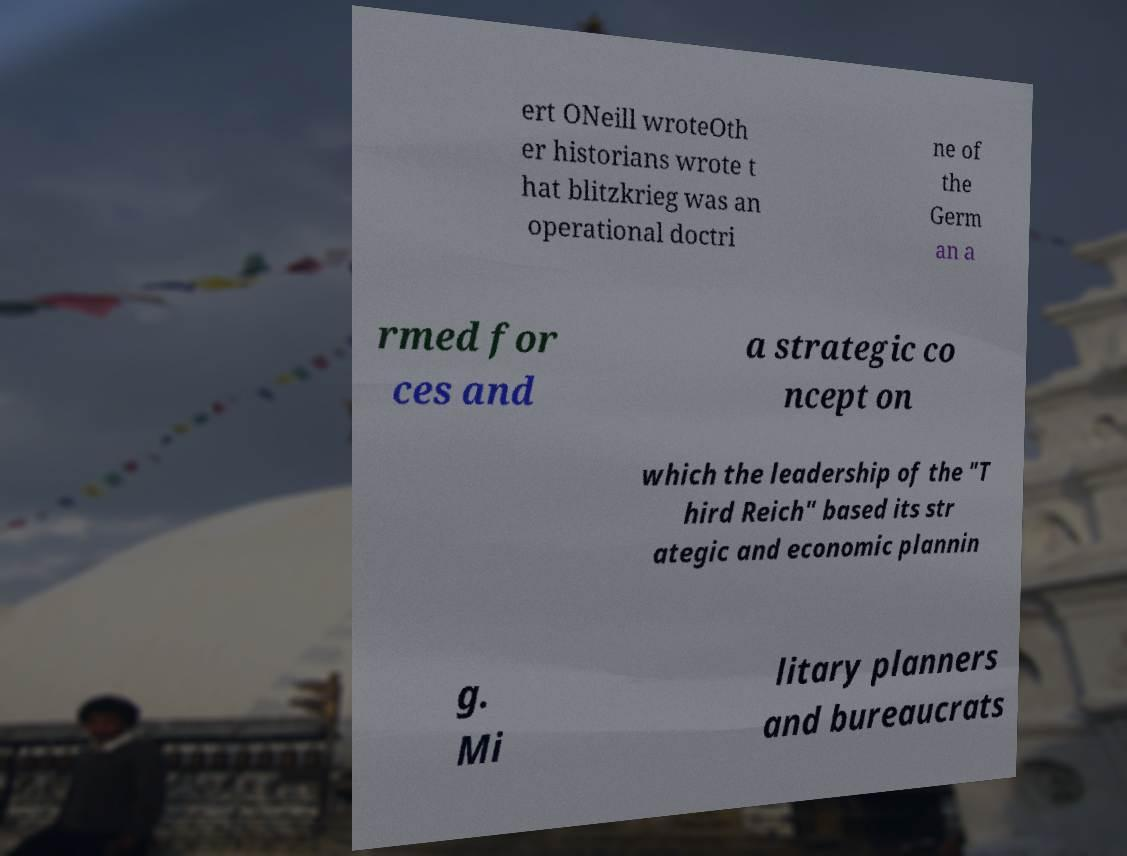I need the written content from this picture converted into text. Can you do that? ert ONeill wroteOth er historians wrote t hat blitzkrieg was an operational doctri ne of the Germ an a rmed for ces and a strategic co ncept on which the leadership of the "T hird Reich" based its str ategic and economic plannin g. Mi litary planners and bureaucrats 